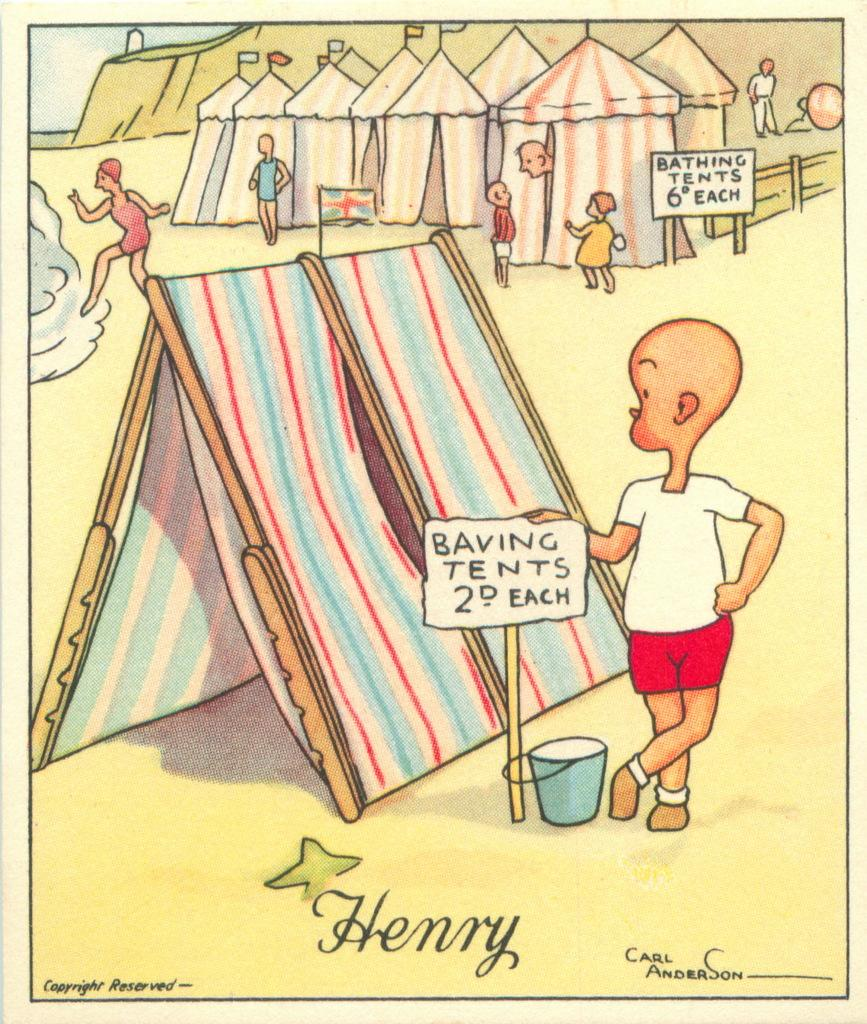What type of image is being described? The image is a drawing. What structures are present in the drawing? There are tents in the drawing. Who is depicted in the drawing? There are kids in the drawing. Is there any text included in the drawing? Yes, there is some text at the bottom of the drawing. Can you tell me how many boys are playing near the river in the drawing? There is no river or boys present in the drawing; it features tents and kids. What type of street is visible in the drawing? There is no street visible in the drawing; it is a drawing of tents and kids with some text at the bottom. 